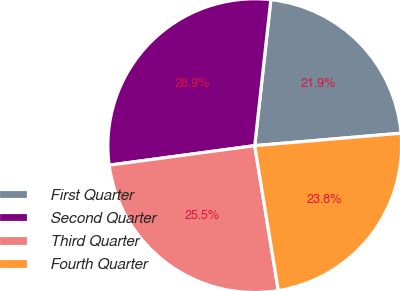<chart> <loc_0><loc_0><loc_500><loc_500><pie_chart><fcel>First Quarter<fcel>Second Quarter<fcel>Third Quarter<fcel>Fourth Quarter<nl><fcel>21.9%<fcel>28.87%<fcel>25.45%<fcel>23.78%<nl></chart> 